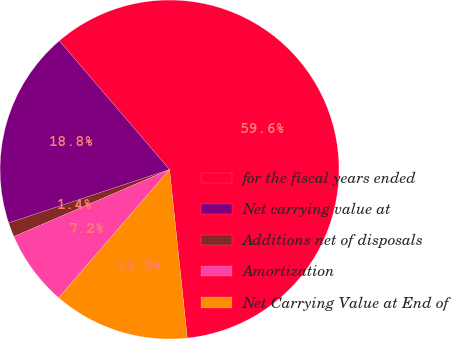Convert chart. <chart><loc_0><loc_0><loc_500><loc_500><pie_chart><fcel>for the fiscal years ended<fcel>Net carrying value at<fcel>Additions net of disposals<fcel>Amortization<fcel>Net Carrying Value at End of<nl><fcel>59.6%<fcel>18.84%<fcel>1.37%<fcel>7.19%<fcel>13.01%<nl></chart> 